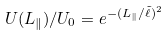Convert formula to latex. <formula><loc_0><loc_0><loc_500><loc_500>U ( L _ { \| } ) / U _ { 0 } = e ^ { - ( L _ { \| } / \tilde { \ell } ) ^ { 2 } }</formula> 